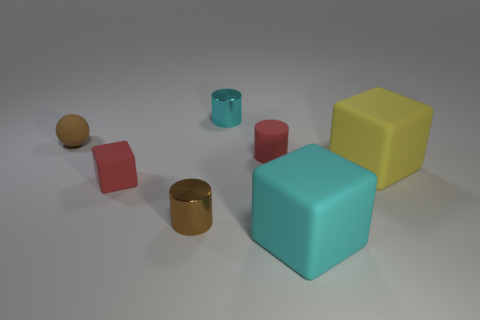Subtract all large cubes. How many cubes are left? 1 Subtract 1 cubes. How many cubes are left? 2 Add 2 brown spheres. How many objects exist? 9 Subtract all brown cubes. Subtract all gray cylinders. How many cubes are left? 3 Subtract all blocks. How many objects are left? 4 Subtract all yellow rubber blocks. Subtract all red matte things. How many objects are left? 4 Add 4 balls. How many balls are left? 5 Add 7 tiny metallic objects. How many tiny metallic objects exist? 9 Subtract 0 blue cylinders. How many objects are left? 7 